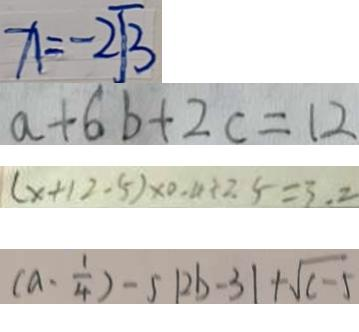<formula> <loc_0><loc_0><loc_500><loc_500>x = - 2 \sqrt { 3 } 
 a + 6 b + 2 c = 1 2 
 ( x + 1 2 - 5 ) \times 0 . 4 + 2 . 5 = 3 . 2 
 ( a \cdot \frac { 1 } { 4 } ) - 5 \vert 2 b - 3 \vert + \sqrt { c - 5 }</formula> 